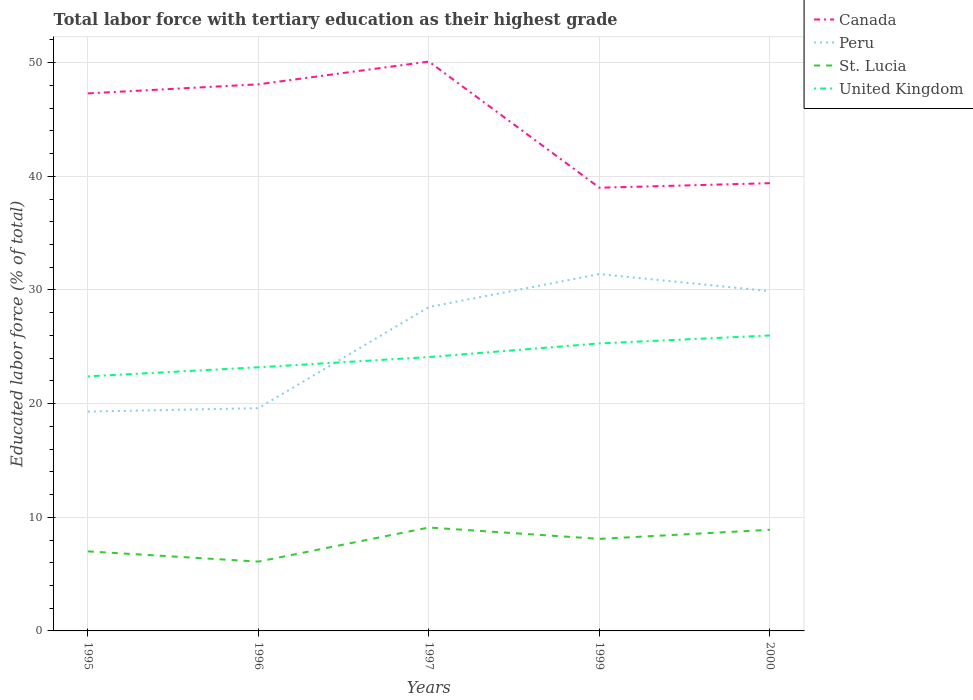Across all years, what is the maximum percentage of male labor force with tertiary education in Peru?
Your response must be concise. 19.3. What is the total percentage of male labor force with tertiary education in Canada in the graph?
Provide a short and direct response. -0.8. What is the difference between the highest and the second highest percentage of male labor force with tertiary education in St. Lucia?
Provide a short and direct response. 3. What is the difference between the highest and the lowest percentage of male labor force with tertiary education in United Kingdom?
Ensure brevity in your answer.  2. Is the percentage of male labor force with tertiary education in Peru strictly greater than the percentage of male labor force with tertiary education in Canada over the years?
Make the answer very short. Yes. How many lines are there?
Ensure brevity in your answer.  4. How many years are there in the graph?
Your answer should be very brief. 5. What is the difference between two consecutive major ticks on the Y-axis?
Keep it short and to the point. 10. Are the values on the major ticks of Y-axis written in scientific E-notation?
Ensure brevity in your answer.  No. Where does the legend appear in the graph?
Your answer should be compact. Top right. How are the legend labels stacked?
Make the answer very short. Vertical. What is the title of the graph?
Your answer should be very brief. Total labor force with tertiary education as their highest grade. What is the label or title of the Y-axis?
Provide a short and direct response. Educated labor force (% of total). What is the Educated labor force (% of total) of Canada in 1995?
Offer a terse response. 47.3. What is the Educated labor force (% of total) of Peru in 1995?
Your answer should be very brief. 19.3. What is the Educated labor force (% of total) in St. Lucia in 1995?
Your answer should be compact. 7. What is the Educated labor force (% of total) in United Kingdom in 1995?
Keep it short and to the point. 22.4. What is the Educated labor force (% of total) of Canada in 1996?
Offer a terse response. 48.1. What is the Educated labor force (% of total) of Peru in 1996?
Make the answer very short. 19.6. What is the Educated labor force (% of total) of St. Lucia in 1996?
Your answer should be compact. 6.1. What is the Educated labor force (% of total) in United Kingdom in 1996?
Offer a very short reply. 23.2. What is the Educated labor force (% of total) of Canada in 1997?
Your answer should be compact. 50.1. What is the Educated labor force (% of total) of St. Lucia in 1997?
Make the answer very short. 9.1. What is the Educated labor force (% of total) of United Kingdom in 1997?
Provide a short and direct response. 24.1. What is the Educated labor force (% of total) in Peru in 1999?
Ensure brevity in your answer.  31.4. What is the Educated labor force (% of total) of St. Lucia in 1999?
Your answer should be compact. 8.1. What is the Educated labor force (% of total) in United Kingdom in 1999?
Make the answer very short. 25.3. What is the Educated labor force (% of total) in Canada in 2000?
Offer a very short reply. 39.4. What is the Educated labor force (% of total) in Peru in 2000?
Your response must be concise. 29.9. What is the Educated labor force (% of total) in St. Lucia in 2000?
Make the answer very short. 8.9. What is the Educated labor force (% of total) of United Kingdom in 2000?
Make the answer very short. 26. Across all years, what is the maximum Educated labor force (% of total) of Canada?
Provide a succinct answer. 50.1. Across all years, what is the maximum Educated labor force (% of total) in Peru?
Make the answer very short. 31.4. Across all years, what is the maximum Educated labor force (% of total) in St. Lucia?
Provide a short and direct response. 9.1. Across all years, what is the minimum Educated labor force (% of total) of Peru?
Offer a terse response. 19.3. Across all years, what is the minimum Educated labor force (% of total) of St. Lucia?
Ensure brevity in your answer.  6.1. Across all years, what is the minimum Educated labor force (% of total) in United Kingdom?
Ensure brevity in your answer.  22.4. What is the total Educated labor force (% of total) in Canada in the graph?
Provide a succinct answer. 223.9. What is the total Educated labor force (% of total) of Peru in the graph?
Your answer should be very brief. 128.7. What is the total Educated labor force (% of total) of St. Lucia in the graph?
Provide a succinct answer. 39.2. What is the total Educated labor force (% of total) of United Kingdom in the graph?
Provide a short and direct response. 121. What is the difference between the Educated labor force (% of total) of Canada in 1995 and that in 1996?
Offer a very short reply. -0.8. What is the difference between the Educated labor force (% of total) in Peru in 1995 and that in 1996?
Offer a terse response. -0.3. What is the difference between the Educated labor force (% of total) of United Kingdom in 1995 and that in 1996?
Offer a very short reply. -0.8. What is the difference between the Educated labor force (% of total) of Peru in 1995 and that in 1997?
Ensure brevity in your answer.  -9.2. What is the difference between the Educated labor force (% of total) of United Kingdom in 1995 and that in 1997?
Give a very brief answer. -1.7. What is the difference between the Educated labor force (% of total) of United Kingdom in 1995 and that in 1999?
Ensure brevity in your answer.  -2.9. What is the difference between the Educated labor force (% of total) of United Kingdom in 1995 and that in 2000?
Your answer should be compact. -3.6. What is the difference between the Educated labor force (% of total) in St. Lucia in 1996 and that in 1997?
Provide a short and direct response. -3. What is the difference between the Educated labor force (% of total) in Peru in 1996 and that in 1999?
Provide a succinct answer. -11.8. What is the difference between the Educated labor force (% of total) of St. Lucia in 1996 and that in 2000?
Provide a short and direct response. -2.8. What is the difference between the Educated labor force (% of total) of Peru in 1997 and that in 1999?
Provide a short and direct response. -2.9. What is the difference between the Educated labor force (% of total) of St. Lucia in 1997 and that in 1999?
Your answer should be very brief. 1. What is the difference between the Educated labor force (% of total) in Peru in 1997 and that in 2000?
Your answer should be very brief. -1.4. What is the difference between the Educated labor force (% of total) in St. Lucia in 1997 and that in 2000?
Your answer should be very brief. 0.2. What is the difference between the Educated labor force (% of total) in United Kingdom in 1997 and that in 2000?
Your answer should be compact. -1.9. What is the difference between the Educated labor force (% of total) of United Kingdom in 1999 and that in 2000?
Your response must be concise. -0.7. What is the difference between the Educated labor force (% of total) of Canada in 1995 and the Educated labor force (% of total) of Peru in 1996?
Give a very brief answer. 27.7. What is the difference between the Educated labor force (% of total) of Canada in 1995 and the Educated labor force (% of total) of St. Lucia in 1996?
Offer a very short reply. 41.2. What is the difference between the Educated labor force (% of total) in Canada in 1995 and the Educated labor force (% of total) in United Kingdom in 1996?
Keep it short and to the point. 24.1. What is the difference between the Educated labor force (% of total) in St. Lucia in 1995 and the Educated labor force (% of total) in United Kingdom in 1996?
Provide a succinct answer. -16.2. What is the difference between the Educated labor force (% of total) in Canada in 1995 and the Educated labor force (% of total) in St. Lucia in 1997?
Your response must be concise. 38.2. What is the difference between the Educated labor force (% of total) in Canada in 1995 and the Educated labor force (% of total) in United Kingdom in 1997?
Offer a terse response. 23.2. What is the difference between the Educated labor force (% of total) of St. Lucia in 1995 and the Educated labor force (% of total) of United Kingdom in 1997?
Ensure brevity in your answer.  -17.1. What is the difference between the Educated labor force (% of total) in Canada in 1995 and the Educated labor force (% of total) in St. Lucia in 1999?
Offer a very short reply. 39.2. What is the difference between the Educated labor force (% of total) of Peru in 1995 and the Educated labor force (% of total) of St. Lucia in 1999?
Give a very brief answer. 11.2. What is the difference between the Educated labor force (% of total) of St. Lucia in 1995 and the Educated labor force (% of total) of United Kingdom in 1999?
Give a very brief answer. -18.3. What is the difference between the Educated labor force (% of total) of Canada in 1995 and the Educated labor force (% of total) of Peru in 2000?
Your answer should be very brief. 17.4. What is the difference between the Educated labor force (% of total) in Canada in 1995 and the Educated labor force (% of total) in St. Lucia in 2000?
Offer a terse response. 38.4. What is the difference between the Educated labor force (% of total) of Canada in 1995 and the Educated labor force (% of total) of United Kingdom in 2000?
Ensure brevity in your answer.  21.3. What is the difference between the Educated labor force (% of total) in Peru in 1995 and the Educated labor force (% of total) in United Kingdom in 2000?
Your answer should be compact. -6.7. What is the difference between the Educated labor force (% of total) of St. Lucia in 1995 and the Educated labor force (% of total) of United Kingdom in 2000?
Ensure brevity in your answer.  -19. What is the difference between the Educated labor force (% of total) in Canada in 1996 and the Educated labor force (% of total) in Peru in 1997?
Ensure brevity in your answer.  19.6. What is the difference between the Educated labor force (% of total) of Canada in 1996 and the Educated labor force (% of total) of United Kingdom in 1997?
Offer a very short reply. 24. What is the difference between the Educated labor force (% of total) in Peru in 1996 and the Educated labor force (% of total) in United Kingdom in 1997?
Offer a very short reply. -4.5. What is the difference between the Educated labor force (% of total) in St. Lucia in 1996 and the Educated labor force (% of total) in United Kingdom in 1997?
Your answer should be very brief. -18. What is the difference between the Educated labor force (% of total) in Canada in 1996 and the Educated labor force (% of total) in Peru in 1999?
Your answer should be compact. 16.7. What is the difference between the Educated labor force (% of total) in Canada in 1996 and the Educated labor force (% of total) in United Kingdom in 1999?
Your answer should be very brief. 22.8. What is the difference between the Educated labor force (% of total) of Peru in 1996 and the Educated labor force (% of total) of United Kingdom in 1999?
Provide a short and direct response. -5.7. What is the difference between the Educated labor force (% of total) of St. Lucia in 1996 and the Educated labor force (% of total) of United Kingdom in 1999?
Provide a succinct answer. -19.2. What is the difference between the Educated labor force (% of total) of Canada in 1996 and the Educated labor force (% of total) of Peru in 2000?
Offer a very short reply. 18.2. What is the difference between the Educated labor force (% of total) in Canada in 1996 and the Educated labor force (% of total) in St. Lucia in 2000?
Ensure brevity in your answer.  39.2. What is the difference between the Educated labor force (% of total) of Canada in 1996 and the Educated labor force (% of total) of United Kingdom in 2000?
Your answer should be very brief. 22.1. What is the difference between the Educated labor force (% of total) of St. Lucia in 1996 and the Educated labor force (% of total) of United Kingdom in 2000?
Your response must be concise. -19.9. What is the difference between the Educated labor force (% of total) of Canada in 1997 and the Educated labor force (% of total) of Peru in 1999?
Provide a succinct answer. 18.7. What is the difference between the Educated labor force (% of total) of Canada in 1997 and the Educated labor force (% of total) of St. Lucia in 1999?
Your answer should be very brief. 42. What is the difference between the Educated labor force (% of total) in Canada in 1997 and the Educated labor force (% of total) in United Kingdom in 1999?
Your response must be concise. 24.8. What is the difference between the Educated labor force (% of total) in Peru in 1997 and the Educated labor force (% of total) in St. Lucia in 1999?
Your answer should be compact. 20.4. What is the difference between the Educated labor force (% of total) in Peru in 1997 and the Educated labor force (% of total) in United Kingdom in 1999?
Provide a short and direct response. 3.2. What is the difference between the Educated labor force (% of total) in St. Lucia in 1997 and the Educated labor force (% of total) in United Kingdom in 1999?
Ensure brevity in your answer.  -16.2. What is the difference between the Educated labor force (% of total) in Canada in 1997 and the Educated labor force (% of total) in Peru in 2000?
Provide a succinct answer. 20.2. What is the difference between the Educated labor force (% of total) in Canada in 1997 and the Educated labor force (% of total) in St. Lucia in 2000?
Make the answer very short. 41.2. What is the difference between the Educated labor force (% of total) of Canada in 1997 and the Educated labor force (% of total) of United Kingdom in 2000?
Give a very brief answer. 24.1. What is the difference between the Educated labor force (% of total) of Peru in 1997 and the Educated labor force (% of total) of St. Lucia in 2000?
Your response must be concise. 19.6. What is the difference between the Educated labor force (% of total) in Peru in 1997 and the Educated labor force (% of total) in United Kingdom in 2000?
Offer a very short reply. 2.5. What is the difference between the Educated labor force (% of total) in St. Lucia in 1997 and the Educated labor force (% of total) in United Kingdom in 2000?
Your answer should be compact. -16.9. What is the difference between the Educated labor force (% of total) of Canada in 1999 and the Educated labor force (% of total) of St. Lucia in 2000?
Keep it short and to the point. 30.1. What is the difference between the Educated labor force (% of total) in St. Lucia in 1999 and the Educated labor force (% of total) in United Kingdom in 2000?
Provide a succinct answer. -17.9. What is the average Educated labor force (% of total) in Canada per year?
Your answer should be compact. 44.78. What is the average Educated labor force (% of total) in Peru per year?
Offer a terse response. 25.74. What is the average Educated labor force (% of total) in St. Lucia per year?
Offer a terse response. 7.84. What is the average Educated labor force (% of total) in United Kingdom per year?
Provide a succinct answer. 24.2. In the year 1995, what is the difference between the Educated labor force (% of total) in Canada and Educated labor force (% of total) in Peru?
Give a very brief answer. 28. In the year 1995, what is the difference between the Educated labor force (% of total) in Canada and Educated labor force (% of total) in St. Lucia?
Provide a short and direct response. 40.3. In the year 1995, what is the difference between the Educated labor force (% of total) in Canada and Educated labor force (% of total) in United Kingdom?
Offer a very short reply. 24.9. In the year 1995, what is the difference between the Educated labor force (% of total) in St. Lucia and Educated labor force (% of total) in United Kingdom?
Keep it short and to the point. -15.4. In the year 1996, what is the difference between the Educated labor force (% of total) of Canada and Educated labor force (% of total) of Peru?
Ensure brevity in your answer.  28.5. In the year 1996, what is the difference between the Educated labor force (% of total) in Canada and Educated labor force (% of total) in St. Lucia?
Keep it short and to the point. 42. In the year 1996, what is the difference between the Educated labor force (% of total) of Canada and Educated labor force (% of total) of United Kingdom?
Your response must be concise. 24.9. In the year 1996, what is the difference between the Educated labor force (% of total) of Peru and Educated labor force (% of total) of United Kingdom?
Keep it short and to the point. -3.6. In the year 1996, what is the difference between the Educated labor force (% of total) in St. Lucia and Educated labor force (% of total) in United Kingdom?
Offer a very short reply. -17.1. In the year 1997, what is the difference between the Educated labor force (% of total) in Canada and Educated labor force (% of total) in Peru?
Offer a terse response. 21.6. In the year 1997, what is the difference between the Educated labor force (% of total) in Canada and Educated labor force (% of total) in St. Lucia?
Give a very brief answer. 41. In the year 1997, what is the difference between the Educated labor force (% of total) of Peru and Educated labor force (% of total) of St. Lucia?
Your answer should be very brief. 19.4. In the year 1999, what is the difference between the Educated labor force (% of total) of Canada and Educated labor force (% of total) of Peru?
Provide a succinct answer. 7.6. In the year 1999, what is the difference between the Educated labor force (% of total) of Canada and Educated labor force (% of total) of St. Lucia?
Offer a very short reply. 30.9. In the year 1999, what is the difference between the Educated labor force (% of total) in Canada and Educated labor force (% of total) in United Kingdom?
Make the answer very short. 13.7. In the year 1999, what is the difference between the Educated labor force (% of total) of Peru and Educated labor force (% of total) of St. Lucia?
Keep it short and to the point. 23.3. In the year 1999, what is the difference between the Educated labor force (% of total) of St. Lucia and Educated labor force (% of total) of United Kingdom?
Offer a very short reply. -17.2. In the year 2000, what is the difference between the Educated labor force (% of total) in Canada and Educated labor force (% of total) in Peru?
Provide a succinct answer. 9.5. In the year 2000, what is the difference between the Educated labor force (% of total) of Canada and Educated labor force (% of total) of St. Lucia?
Offer a terse response. 30.5. In the year 2000, what is the difference between the Educated labor force (% of total) in Canada and Educated labor force (% of total) in United Kingdom?
Your response must be concise. 13.4. In the year 2000, what is the difference between the Educated labor force (% of total) of Peru and Educated labor force (% of total) of United Kingdom?
Your answer should be compact. 3.9. In the year 2000, what is the difference between the Educated labor force (% of total) of St. Lucia and Educated labor force (% of total) of United Kingdom?
Make the answer very short. -17.1. What is the ratio of the Educated labor force (% of total) in Canada in 1995 to that in 1996?
Keep it short and to the point. 0.98. What is the ratio of the Educated labor force (% of total) in Peru in 1995 to that in 1996?
Offer a terse response. 0.98. What is the ratio of the Educated labor force (% of total) of St. Lucia in 1995 to that in 1996?
Keep it short and to the point. 1.15. What is the ratio of the Educated labor force (% of total) in United Kingdom in 1995 to that in 1996?
Ensure brevity in your answer.  0.97. What is the ratio of the Educated labor force (% of total) in Canada in 1995 to that in 1997?
Offer a very short reply. 0.94. What is the ratio of the Educated labor force (% of total) of Peru in 1995 to that in 1997?
Ensure brevity in your answer.  0.68. What is the ratio of the Educated labor force (% of total) in St. Lucia in 1995 to that in 1997?
Keep it short and to the point. 0.77. What is the ratio of the Educated labor force (% of total) in United Kingdom in 1995 to that in 1997?
Keep it short and to the point. 0.93. What is the ratio of the Educated labor force (% of total) of Canada in 1995 to that in 1999?
Give a very brief answer. 1.21. What is the ratio of the Educated labor force (% of total) of Peru in 1995 to that in 1999?
Offer a very short reply. 0.61. What is the ratio of the Educated labor force (% of total) in St. Lucia in 1995 to that in 1999?
Offer a very short reply. 0.86. What is the ratio of the Educated labor force (% of total) of United Kingdom in 1995 to that in 1999?
Offer a very short reply. 0.89. What is the ratio of the Educated labor force (% of total) of Canada in 1995 to that in 2000?
Provide a succinct answer. 1.2. What is the ratio of the Educated labor force (% of total) of Peru in 1995 to that in 2000?
Ensure brevity in your answer.  0.65. What is the ratio of the Educated labor force (% of total) in St. Lucia in 1995 to that in 2000?
Provide a succinct answer. 0.79. What is the ratio of the Educated labor force (% of total) in United Kingdom in 1995 to that in 2000?
Your answer should be very brief. 0.86. What is the ratio of the Educated labor force (% of total) of Canada in 1996 to that in 1997?
Ensure brevity in your answer.  0.96. What is the ratio of the Educated labor force (% of total) of Peru in 1996 to that in 1997?
Give a very brief answer. 0.69. What is the ratio of the Educated labor force (% of total) in St. Lucia in 1996 to that in 1997?
Your answer should be compact. 0.67. What is the ratio of the Educated labor force (% of total) of United Kingdom in 1996 to that in 1997?
Your response must be concise. 0.96. What is the ratio of the Educated labor force (% of total) in Canada in 1996 to that in 1999?
Keep it short and to the point. 1.23. What is the ratio of the Educated labor force (% of total) in Peru in 1996 to that in 1999?
Your response must be concise. 0.62. What is the ratio of the Educated labor force (% of total) in St. Lucia in 1996 to that in 1999?
Ensure brevity in your answer.  0.75. What is the ratio of the Educated labor force (% of total) in United Kingdom in 1996 to that in 1999?
Your answer should be compact. 0.92. What is the ratio of the Educated labor force (% of total) in Canada in 1996 to that in 2000?
Offer a terse response. 1.22. What is the ratio of the Educated labor force (% of total) in Peru in 1996 to that in 2000?
Your answer should be compact. 0.66. What is the ratio of the Educated labor force (% of total) of St. Lucia in 1996 to that in 2000?
Offer a terse response. 0.69. What is the ratio of the Educated labor force (% of total) in United Kingdom in 1996 to that in 2000?
Give a very brief answer. 0.89. What is the ratio of the Educated labor force (% of total) in Canada in 1997 to that in 1999?
Keep it short and to the point. 1.28. What is the ratio of the Educated labor force (% of total) of Peru in 1997 to that in 1999?
Provide a short and direct response. 0.91. What is the ratio of the Educated labor force (% of total) in St. Lucia in 1997 to that in 1999?
Your answer should be very brief. 1.12. What is the ratio of the Educated labor force (% of total) in United Kingdom in 1997 to that in 1999?
Keep it short and to the point. 0.95. What is the ratio of the Educated labor force (% of total) of Canada in 1997 to that in 2000?
Offer a very short reply. 1.27. What is the ratio of the Educated labor force (% of total) in Peru in 1997 to that in 2000?
Keep it short and to the point. 0.95. What is the ratio of the Educated labor force (% of total) in St. Lucia in 1997 to that in 2000?
Offer a terse response. 1.02. What is the ratio of the Educated labor force (% of total) in United Kingdom in 1997 to that in 2000?
Provide a short and direct response. 0.93. What is the ratio of the Educated labor force (% of total) of Peru in 1999 to that in 2000?
Give a very brief answer. 1.05. What is the ratio of the Educated labor force (% of total) of St. Lucia in 1999 to that in 2000?
Offer a very short reply. 0.91. What is the ratio of the Educated labor force (% of total) of United Kingdom in 1999 to that in 2000?
Make the answer very short. 0.97. What is the difference between the highest and the second highest Educated labor force (% of total) in United Kingdom?
Provide a succinct answer. 0.7. What is the difference between the highest and the lowest Educated labor force (% of total) of Peru?
Make the answer very short. 12.1. What is the difference between the highest and the lowest Educated labor force (% of total) of St. Lucia?
Your answer should be compact. 3. What is the difference between the highest and the lowest Educated labor force (% of total) of United Kingdom?
Ensure brevity in your answer.  3.6. 